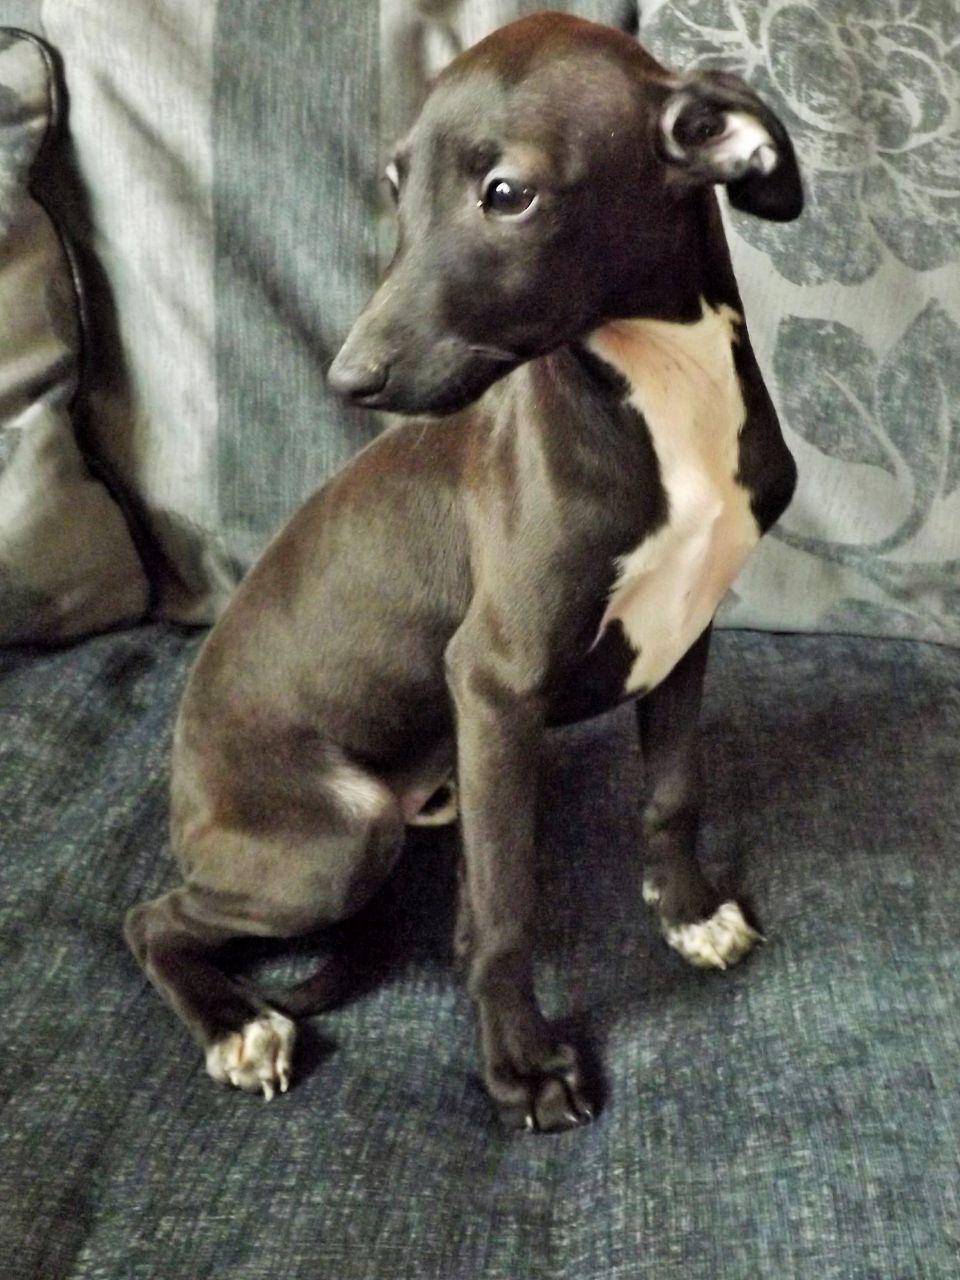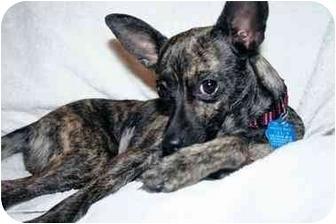The first image is the image on the left, the second image is the image on the right. For the images shown, is this caption "At least one of the dogs is on a leash." true? Answer yes or no. No. The first image is the image on the left, the second image is the image on the right. Examine the images to the left and right. Is the description "At least one greyhound is wearing something red." accurate? Answer yes or no. No. 